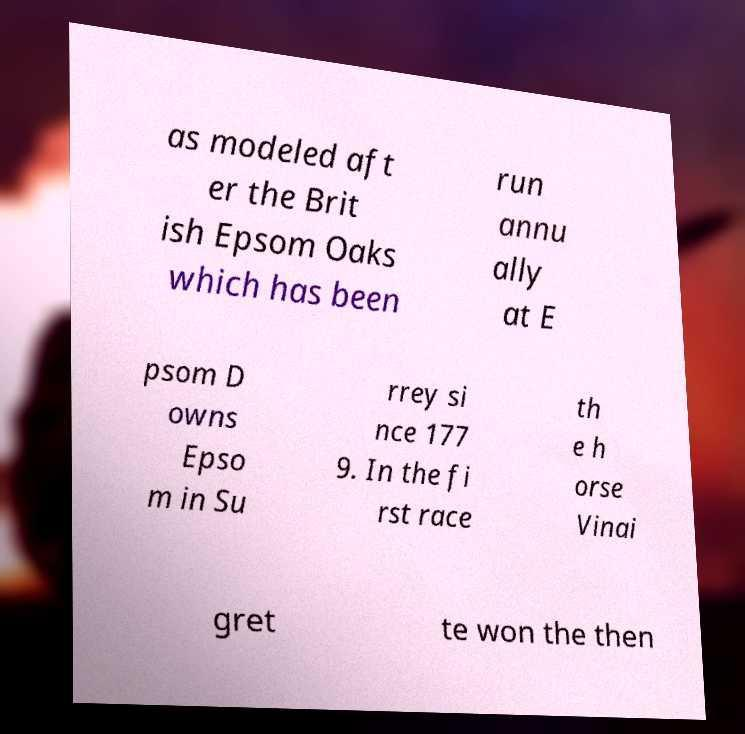Could you assist in decoding the text presented in this image and type it out clearly? as modeled aft er the Brit ish Epsom Oaks which has been run annu ally at E psom D owns Epso m in Su rrey si nce 177 9. In the fi rst race th e h orse Vinai gret te won the then 